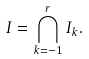<formula> <loc_0><loc_0><loc_500><loc_500>I = \bigcap _ { k = - 1 } ^ { r } I _ { k } .</formula> 